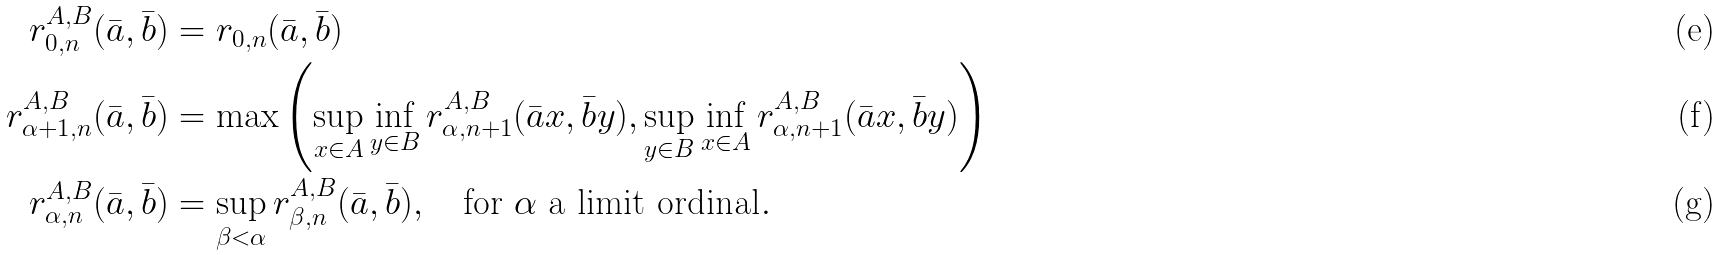Convert formula to latex. <formula><loc_0><loc_0><loc_500><loc_500>r _ { 0 , n } ^ { A , B } ( \bar { a } , \bar { b } ) & = r _ { 0 , n } ( \bar { a } , \bar { b } ) \\ r _ { \alpha + 1 , n } ^ { A , B } ( \bar { a } , \bar { b } ) & = \max \left ( \sup _ { x \in A } \inf _ { y \in B } r _ { \alpha , n + 1 } ^ { A , B } ( \bar { a } x , \bar { b } y ) , \sup _ { y \in B } \inf _ { x \in A } r _ { \alpha , n + 1 } ^ { A , B } ( \bar { a } x , \bar { b } y ) \right ) \\ r _ { \alpha , n } ^ { A , B } ( \bar { a } , \bar { b } ) & = \sup _ { \beta < \alpha } r _ { \beta , n } ^ { A , B } ( \bar { a } , \bar { b } ) , \quad \text {for } \alpha \ \text {a limit ordinal} .</formula> 